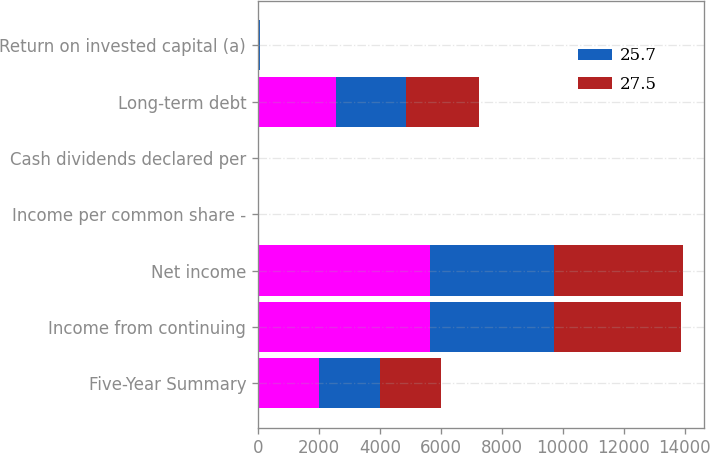Convert chart. <chart><loc_0><loc_0><loc_500><loc_500><stacked_bar_chart><ecel><fcel>Five-Year Summary<fcel>Income from continuing<fcel>Net income<fcel>Income per common share -<fcel>Cash dividends declared per<fcel>Long-term debt<fcel>Return on invested capital (a)<nl><fcel>nan<fcel>2006<fcel>5642<fcel>5642<fcel>3.34<fcel>1.16<fcel>2550<fcel>30.4<nl><fcel>25.7<fcel>2005<fcel>4078<fcel>4078<fcel>2.39<fcel>1.01<fcel>2313<fcel>22.7<nl><fcel>27.5<fcel>2004<fcel>4174<fcel>4212<fcel>2.41<fcel>0.85<fcel>2397<fcel>27.4<nl></chart> 